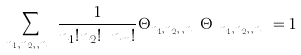Convert formula to latex. <formula><loc_0><loc_0><loc_500><loc_500>\sum _ { n _ { 1 } , n _ { 2 } , \cdots , n _ { m } } \frac { 1 } { n _ { 1 } ! n _ { 2 } ! \cdots n _ { m } ! } \Theta _ { n _ { 1 } , n _ { 2 } , \cdots , n _ { m } } { \Theta ^ { \dagger } } _ { n _ { 1 } , n _ { 2 } , \cdots , n _ { m } } = 1</formula> 